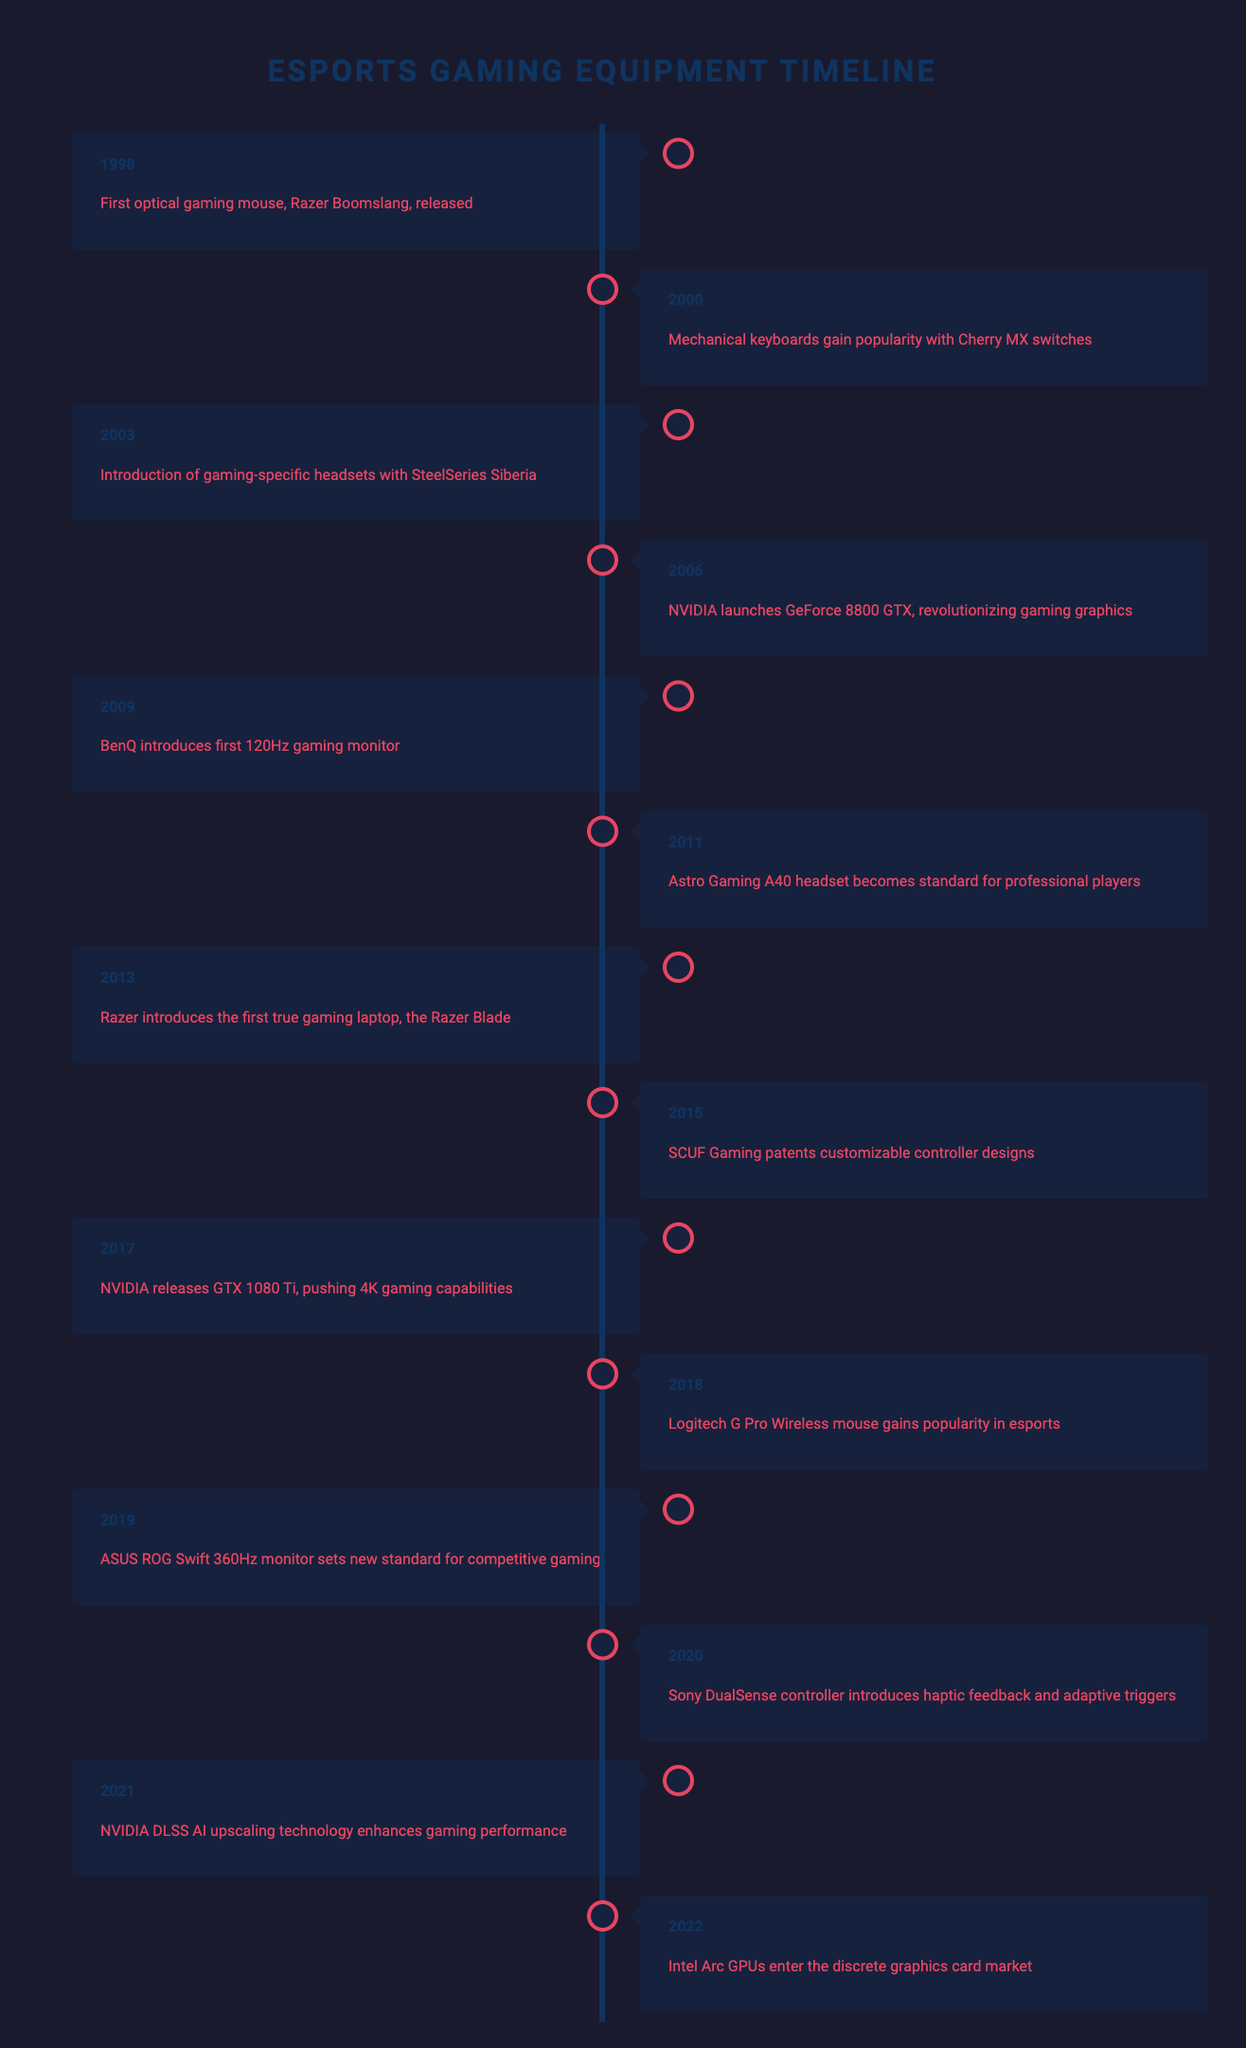What significant gaming equipment was introduced in 2006? According to the table, the significant event in 2006 was the launch of the NVIDIA GeForce 8800 GTX, which is noted for revolutionizing gaming graphics.
Answer: NVIDIA GeForce 8800 GTX What year did SCUF Gaming patent customizable controller designs? The table states that SCUF Gaming patented customizable controller designs in 2015.
Answer: 2015 How many years passed between the release of the first optical gaming mouse and the introduction of gaming-specific headsets? The first optical gaming mouse (Razer Boomslang) was released in 1998 and gaming-specific headsets (SteelSeries Siberia) were introduced in 2003. The difference is 2003 - 1998 = 5 years.
Answer: 5 years Was the Astro Gaming A40 headset introduced before the first 120Hz gaming monitor? Yes, the Astro Gaming A40 headset became a standard for professional players in 2011, and the first 120Hz gaming monitor was introduced in 2009. Therefore, the Astro headset was introduced after the BenQ monitor.
Answer: No What was the average year of introduction for the gaming-specific equipment listed? The years of introduction for each item are: 1998, 2000, 2003, 2006, 2009, 2011, 2013, 2015, 2017, 2018, 2019, 2020, 2021, and 2022. There are 14 data points, and their sum is 1998 + 2000 + 2003 + 2006 + 2009 + 2011 + 2013 + 2015 + 2017 + 2018 + 2019 + 2020 + 2021 + 2022 = 28125. The average is 28125 / 14 = 2008.21, which rounds to 2008.
Answer: 2008 What event related to gaming monitor technology happened in 2019? The event in 2019 was that the ASUS ROG Swift 360Hz monitor set a new standard for competitive gaming. This indicates a significant advancement in monitor technology for esports.
Answer: ASUS ROG Swift 360Hz monitor set new standard for competitive gaming 